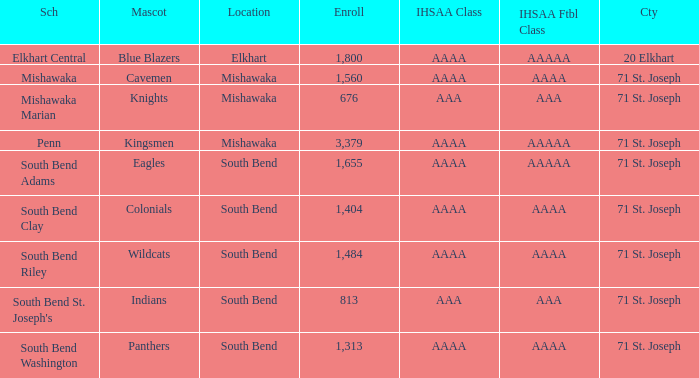What IHSAA Football Class has 20 elkhart as the county? AAAAA. 